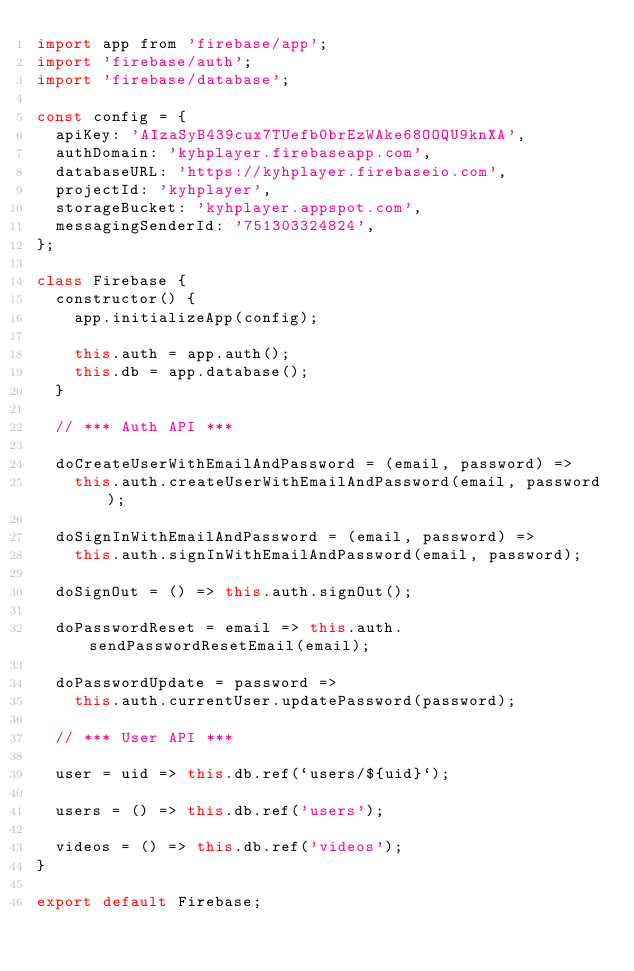<code> <loc_0><loc_0><loc_500><loc_500><_JavaScript_>import app from 'firebase/app';
import 'firebase/auth';
import 'firebase/database';

const config = {
  apiKey: 'AIzaSyB439cux7TUefb0brEzWAke68OOQU9knXA',
  authDomain: 'kyhplayer.firebaseapp.com',
  databaseURL: 'https://kyhplayer.firebaseio.com',
  projectId: 'kyhplayer',
  storageBucket: 'kyhplayer.appspot.com',
  messagingSenderId: '751303324824',
};

class Firebase {
  constructor() {
    app.initializeApp(config);

    this.auth = app.auth();
    this.db = app.database();
  }

  // *** Auth API ***

  doCreateUserWithEmailAndPassword = (email, password) =>
    this.auth.createUserWithEmailAndPassword(email, password);

  doSignInWithEmailAndPassword = (email, password) =>
    this.auth.signInWithEmailAndPassword(email, password);

  doSignOut = () => this.auth.signOut();

  doPasswordReset = email => this.auth.sendPasswordResetEmail(email);

  doPasswordUpdate = password =>
    this.auth.currentUser.updatePassword(password);

  // *** User API ***

  user = uid => this.db.ref(`users/${uid}`);

  users = () => this.db.ref('users');

  videos = () => this.db.ref('videos');
}

export default Firebase;
</code> 